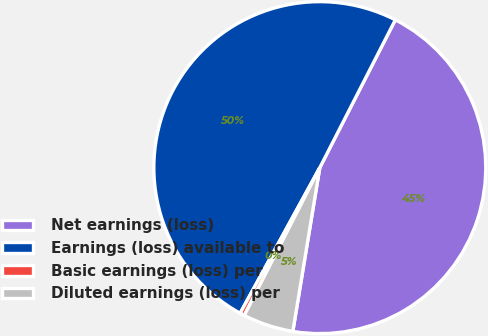<chart> <loc_0><loc_0><loc_500><loc_500><pie_chart><fcel>Net earnings (loss)<fcel>Earnings (loss) available to<fcel>Basic earnings (loss) per<fcel>Diluted earnings (loss) per<nl><fcel>45.08%<fcel>49.55%<fcel>0.45%<fcel>4.92%<nl></chart> 